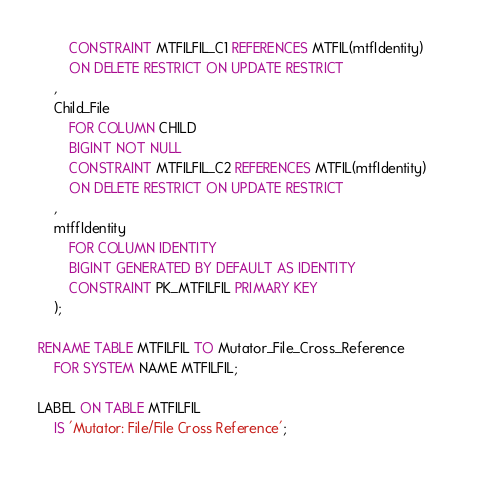<code> <loc_0><loc_0><loc_500><loc_500><_SQL_>        CONSTRAINT MTFILFIL_C1 REFERENCES MTFIL(mtfIdentity)      
        ON DELETE RESTRICT ON UPDATE RESTRICT                    
    ,                                                            
    Child_File   
        FOR COLUMN CHILD                                                
        BIGINT NOT NULL                                          
        CONSTRAINT MTFILFIL_C2 REFERENCES MTFIL(mtfIdentity)      
        ON DELETE RESTRICT ON UPDATE RESTRICT                    
    ,                                                            
    mtffIdentity                                 
        FOR COLUMN IDENTITY                    
        BIGINT GENERATED BY DEFAULT AS IDENTITY                  
        CONSTRAINT PK_MTFILFIL PRIMARY KEY                       
    );                                                           
        
RENAME TABLE MTFILFIL TO Mutator_File_Cross_Reference
    FOR SYSTEM NAME MTFILFIL;            

LABEL ON TABLE MTFILFIL                 
    IS 'Mutator: File/File Cross Reference';              
                                        </code> 